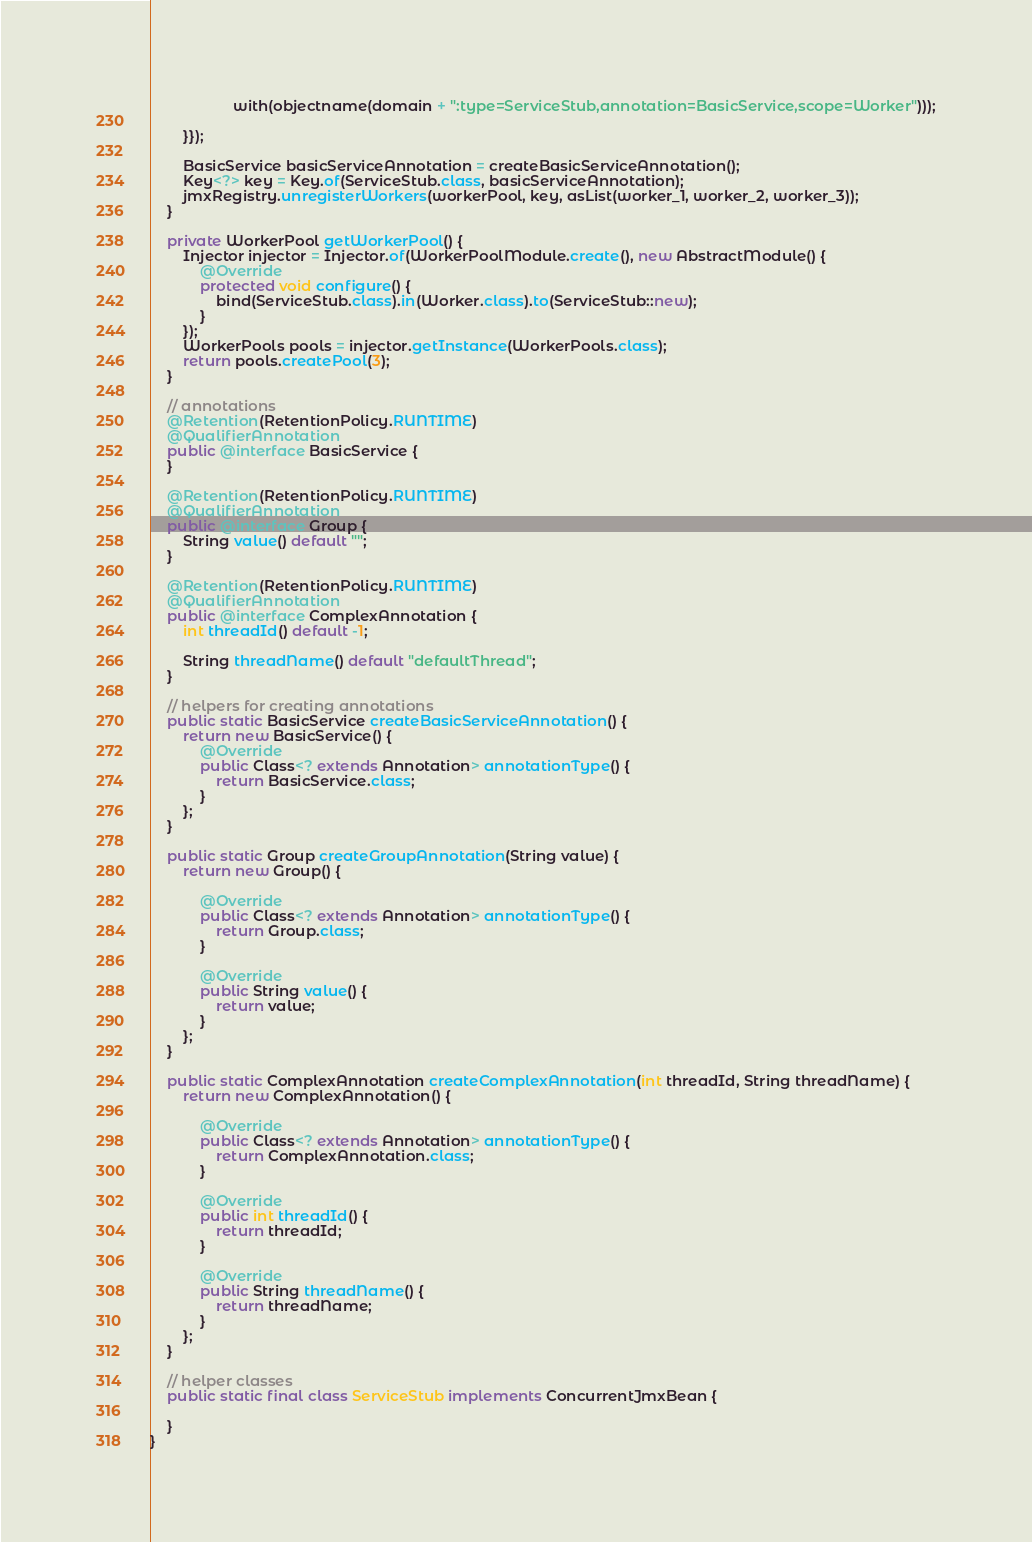<code> <loc_0><loc_0><loc_500><loc_500><_Java_>					with(objectname(domain + ":type=ServiceStub,annotation=BasicService,scope=Worker")));

		}});

		BasicService basicServiceAnnotation = createBasicServiceAnnotation();
		Key<?> key = Key.of(ServiceStub.class, basicServiceAnnotation);
		jmxRegistry.unregisterWorkers(workerPool, key, asList(worker_1, worker_2, worker_3));
	}

	private WorkerPool getWorkerPool() {
		Injector injector = Injector.of(WorkerPoolModule.create(), new AbstractModule() {
			@Override
			protected void configure() {
				bind(ServiceStub.class).in(Worker.class).to(ServiceStub::new);
			}
		});
		WorkerPools pools = injector.getInstance(WorkerPools.class);
		return pools.createPool(3);
	}

	// annotations
	@Retention(RetentionPolicy.RUNTIME)
	@QualifierAnnotation
	public @interface BasicService {
	}

	@Retention(RetentionPolicy.RUNTIME)
	@QualifierAnnotation
	public @interface Group {
		String value() default "";
	}

	@Retention(RetentionPolicy.RUNTIME)
	@QualifierAnnotation
	public @interface ComplexAnnotation {
		int threadId() default -1;

		String threadName() default "defaultThread";
	}

	// helpers for creating annotations
	public static BasicService createBasicServiceAnnotation() {
		return new BasicService() {
			@Override
			public Class<? extends Annotation> annotationType() {
				return BasicService.class;
			}
		};
	}

	public static Group createGroupAnnotation(String value) {
		return new Group() {

			@Override
			public Class<? extends Annotation> annotationType() {
				return Group.class;
			}

			@Override
			public String value() {
				return value;
			}
		};
	}

	public static ComplexAnnotation createComplexAnnotation(int threadId, String threadName) {
		return new ComplexAnnotation() {

			@Override
			public Class<? extends Annotation> annotationType() {
				return ComplexAnnotation.class;
			}

			@Override
			public int threadId() {
				return threadId;
			}

			@Override
			public String threadName() {
				return threadName;
			}
		};
	}

	// helper classes
	public static final class ServiceStub implements ConcurrentJmxBean {

	}
}
</code> 